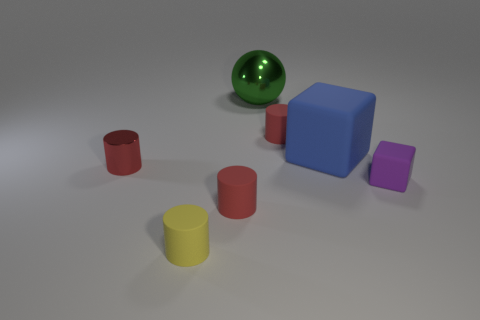What number of other objects are the same shape as the green object?
Make the answer very short. 0. Is the color of the rubber cylinder to the right of the big green ball the same as the tiny metallic cylinder?
Your response must be concise. Yes. What size is the other object that is the same shape as the purple object?
Your answer should be very brief. Large. There is a tiny rubber cylinder that is behind the small matte object to the right of the small cylinder behind the big blue object; what color is it?
Offer a very short reply. Red. Are the blue block and the small yellow object made of the same material?
Provide a short and direct response. Yes. There is a small cylinder in front of the red rubber thing in front of the tiny purple rubber block; is there a object left of it?
Provide a short and direct response. Yes. Is the number of big purple shiny objects less than the number of large blue things?
Provide a succinct answer. Yes. Is the material of the red object behind the large blue cube the same as the small red object to the left of the small yellow thing?
Ensure brevity in your answer.  No. Is the number of purple blocks that are behind the green shiny object less than the number of big blue rubber things?
Offer a very short reply. Yes. There is a shiny object in front of the large metallic sphere; what number of small red rubber things are behind it?
Provide a short and direct response. 1. 